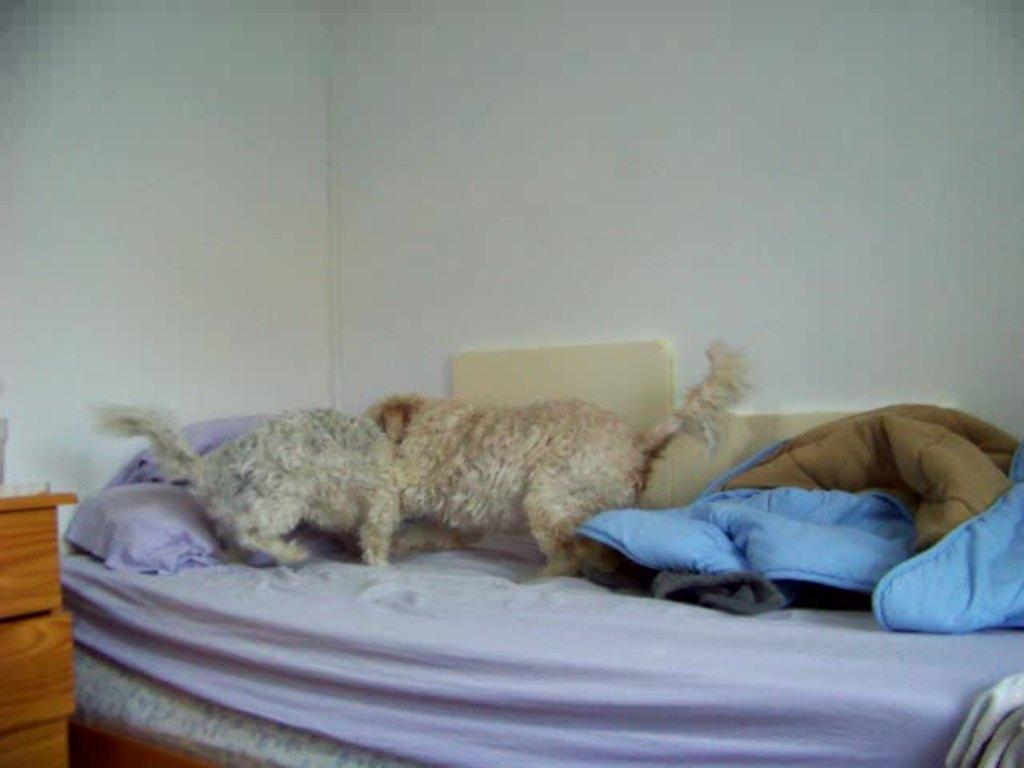What is the main piece of furniture in the image? There is a bed in the image. What is placed on the bed? There are pillows and a bed sheet on the bed. What activity are the dogs engaged in on the bed? Two dogs are playing on the bed. What color is the wall visible in the background? There is a white color wall in the background. What type of storage furniture is present in the image? There is a cupboard in the left corner of the image. What type of account is being discussed in the image? There is no discussion of an account in the image; it features a bed with pillows, a bed sheet, two dogs playing, a white wall, and a cupboard. 